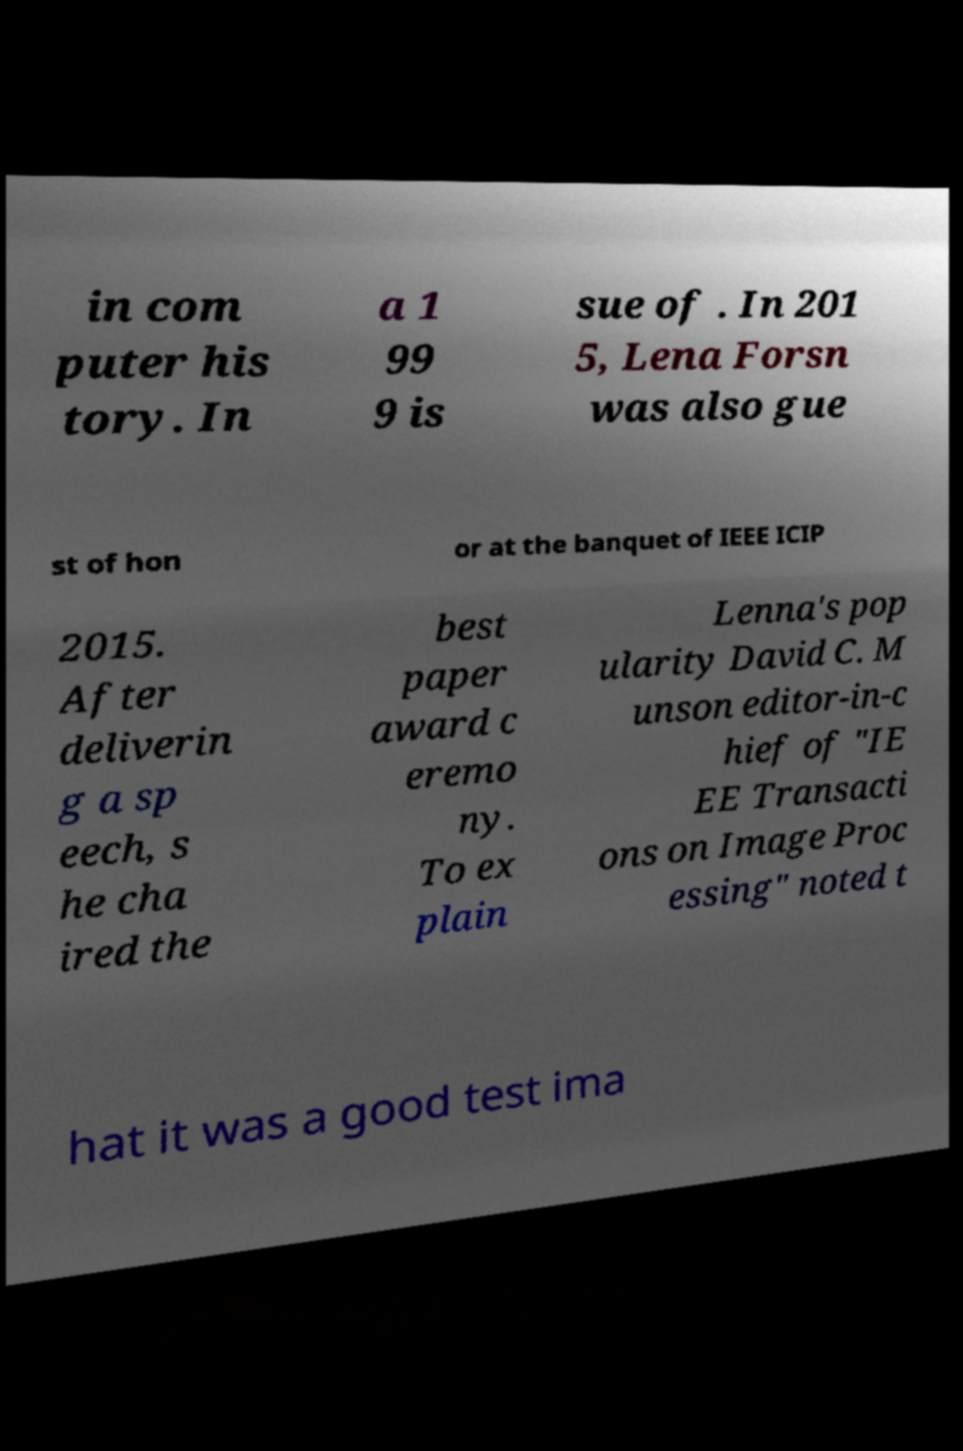I need the written content from this picture converted into text. Can you do that? in com puter his tory. In a 1 99 9 is sue of . In 201 5, Lena Forsn was also gue st of hon or at the banquet of IEEE ICIP 2015. After deliverin g a sp eech, s he cha ired the best paper award c eremo ny. To ex plain Lenna's pop ularity David C. M unson editor-in-c hief of "IE EE Transacti ons on Image Proc essing" noted t hat it was a good test ima 